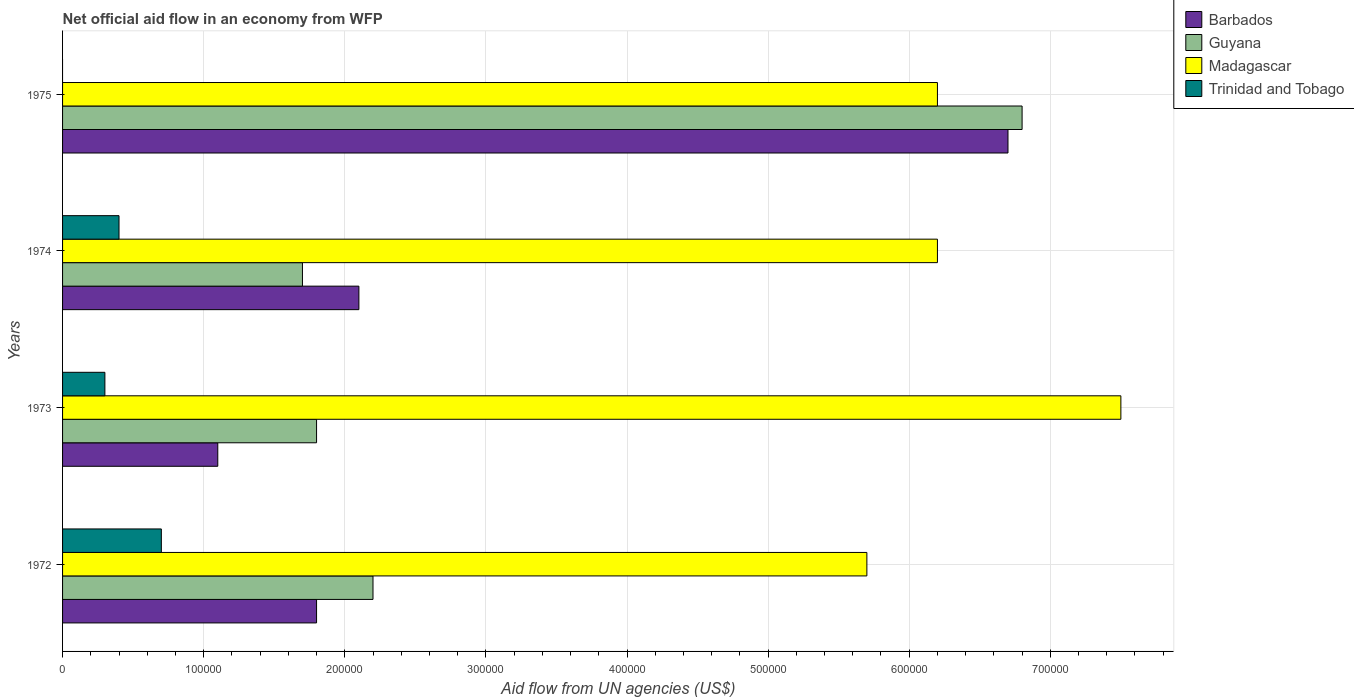How many groups of bars are there?
Your answer should be very brief. 4. How many bars are there on the 4th tick from the top?
Your answer should be compact. 4. What is the label of the 1st group of bars from the top?
Keep it short and to the point. 1975. What is the net official aid flow in Madagascar in 1973?
Provide a succinct answer. 7.50e+05. Across all years, what is the maximum net official aid flow in Trinidad and Tobago?
Provide a succinct answer. 7.00e+04. In which year was the net official aid flow in Barbados maximum?
Ensure brevity in your answer.  1975. What is the total net official aid flow in Barbados in the graph?
Your response must be concise. 1.17e+06. What is the difference between the net official aid flow in Guyana in 1973 and that in 1975?
Your answer should be compact. -5.00e+05. What is the average net official aid flow in Guyana per year?
Ensure brevity in your answer.  3.12e+05. In the year 1975, what is the difference between the net official aid flow in Barbados and net official aid flow in Guyana?
Keep it short and to the point. -10000. In how many years, is the net official aid flow in Madagascar greater than 120000 US$?
Give a very brief answer. 4. What is the ratio of the net official aid flow in Barbados in 1972 to that in 1973?
Provide a succinct answer. 1.64. What is the difference between the highest and the second highest net official aid flow in Trinidad and Tobago?
Keep it short and to the point. 3.00e+04. What is the difference between the highest and the lowest net official aid flow in Guyana?
Your answer should be compact. 5.10e+05. Is the sum of the net official aid flow in Barbados in 1973 and 1975 greater than the maximum net official aid flow in Madagascar across all years?
Make the answer very short. Yes. Is it the case that in every year, the sum of the net official aid flow in Barbados and net official aid flow in Madagascar is greater than the sum of net official aid flow in Guyana and net official aid flow in Trinidad and Tobago?
Offer a terse response. No. Is it the case that in every year, the sum of the net official aid flow in Trinidad and Tobago and net official aid flow in Guyana is greater than the net official aid flow in Barbados?
Offer a terse response. No. Are all the bars in the graph horizontal?
Your response must be concise. Yes. How many years are there in the graph?
Provide a succinct answer. 4. Does the graph contain any zero values?
Ensure brevity in your answer.  Yes. Does the graph contain grids?
Your answer should be compact. Yes. How are the legend labels stacked?
Offer a terse response. Vertical. What is the title of the graph?
Your answer should be very brief. Net official aid flow in an economy from WFP. Does "Bosnia and Herzegovina" appear as one of the legend labels in the graph?
Provide a succinct answer. No. What is the label or title of the X-axis?
Offer a very short reply. Aid flow from UN agencies (US$). What is the label or title of the Y-axis?
Provide a short and direct response. Years. What is the Aid flow from UN agencies (US$) of Madagascar in 1972?
Your answer should be very brief. 5.70e+05. What is the Aid flow from UN agencies (US$) of Trinidad and Tobago in 1972?
Offer a terse response. 7.00e+04. What is the Aid flow from UN agencies (US$) of Barbados in 1973?
Give a very brief answer. 1.10e+05. What is the Aid flow from UN agencies (US$) in Guyana in 1973?
Ensure brevity in your answer.  1.80e+05. What is the Aid flow from UN agencies (US$) in Madagascar in 1973?
Ensure brevity in your answer.  7.50e+05. What is the Aid flow from UN agencies (US$) of Trinidad and Tobago in 1973?
Offer a very short reply. 3.00e+04. What is the Aid flow from UN agencies (US$) of Barbados in 1974?
Your response must be concise. 2.10e+05. What is the Aid flow from UN agencies (US$) of Madagascar in 1974?
Make the answer very short. 6.20e+05. What is the Aid flow from UN agencies (US$) of Barbados in 1975?
Provide a succinct answer. 6.70e+05. What is the Aid flow from UN agencies (US$) of Guyana in 1975?
Provide a short and direct response. 6.80e+05. What is the Aid flow from UN agencies (US$) in Madagascar in 1975?
Make the answer very short. 6.20e+05. What is the Aid flow from UN agencies (US$) in Trinidad and Tobago in 1975?
Make the answer very short. 0. Across all years, what is the maximum Aid flow from UN agencies (US$) in Barbados?
Your answer should be compact. 6.70e+05. Across all years, what is the maximum Aid flow from UN agencies (US$) of Guyana?
Your answer should be compact. 6.80e+05. Across all years, what is the maximum Aid flow from UN agencies (US$) of Madagascar?
Offer a very short reply. 7.50e+05. Across all years, what is the maximum Aid flow from UN agencies (US$) in Trinidad and Tobago?
Provide a short and direct response. 7.00e+04. Across all years, what is the minimum Aid flow from UN agencies (US$) of Madagascar?
Provide a short and direct response. 5.70e+05. Across all years, what is the minimum Aid flow from UN agencies (US$) of Trinidad and Tobago?
Offer a terse response. 0. What is the total Aid flow from UN agencies (US$) of Barbados in the graph?
Give a very brief answer. 1.17e+06. What is the total Aid flow from UN agencies (US$) in Guyana in the graph?
Give a very brief answer. 1.25e+06. What is the total Aid flow from UN agencies (US$) in Madagascar in the graph?
Provide a short and direct response. 2.56e+06. What is the total Aid flow from UN agencies (US$) of Trinidad and Tobago in the graph?
Ensure brevity in your answer.  1.40e+05. What is the difference between the Aid flow from UN agencies (US$) in Barbados in 1972 and that in 1973?
Your answer should be compact. 7.00e+04. What is the difference between the Aid flow from UN agencies (US$) of Trinidad and Tobago in 1972 and that in 1973?
Provide a succinct answer. 4.00e+04. What is the difference between the Aid flow from UN agencies (US$) in Guyana in 1972 and that in 1974?
Offer a terse response. 5.00e+04. What is the difference between the Aid flow from UN agencies (US$) of Barbados in 1972 and that in 1975?
Make the answer very short. -4.90e+05. What is the difference between the Aid flow from UN agencies (US$) of Guyana in 1972 and that in 1975?
Offer a terse response. -4.60e+05. What is the difference between the Aid flow from UN agencies (US$) in Madagascar in 1972 and that in 1975?
Offer a terse response. -5.00e+04. What is the difference between the Aid flow from UN agencies (US$) in Guyana in 1973 and that in 1974?
Make the answer very short. 10000. What is the difference between the Aid flow from UN agencies (US$) of Barbados in 1973 and that in 1975?
Offer a very short reply. -5.60e+05. What is the difference between the Aid flow from UN agencies (US$) of Guyana in 1973 and that in 1975?
Your answer should be compact. -5.00e+05. What is the difference between the Aid flow from UN agencies (US$) in Madagascar in 1973 and that in 1975?
Keep it short and to the point. 1.30e+05. What is the difference between the Aid flow from UN agencies (US$) of Barbados in 1974 and that in 1975?
Ensure brevity in your answer.  -4.60e+05. What is the difference between the Aid flow from UN agencies (US$) of Guyana in 1974 and that in 1975?
Give a very brief answer. -5.10e+05. What is the difference between the Aid flow from UN agencies (US$) of Madagascar in 1974 and that in 1975?
Your response must be concise. 0. What is the difference between the Aid flow from UN agencies (US$) in Barbados in 1972 and the Aid flow from UN agencies (US$) in Madagascar in 1973?
Your response must be concise. -5.70e+05. What is the difference between the Aid flow from UN agencies (US$) in Guyana in 1972 and the Aid flow from UN agencies (US$) in Madagascar in 1973?
Your response must be concise. -5.30e+05. What is the difference between the Aid flow from UN agencies (US$) in Madagascar in 1972 and the Aid flow from UN agencies (US$) in Trinidad and Tobago in 1973?
Offer a very short reply. 5.40e+05. What is the difference between the Aid flow from UN agencies (US$) of Barbados in 1972 and the Aid flow from UN agencies (US$) of Madagascar in 1974?
Your answer should be very brief. -4.40e+05. What is the difference between the Aid flow from UN agencies (US$) in Barbados in 1972 and the Aid flow from UN agencies (US$) in Trinidad and Tobago in 1974?
Ensure brevity in your answer.  1.40e+05. What is the difference between the Aid flow from UN agencies (US$) of Guyana in 1972 and the Aid flow from UN agencies (US$) of Madagascar in 1974?
Provide a succinct answer. -4.00e+05. What is the difference between the Aid flow from UN agencies (US$) in Guyana in 1972 and the Aid flow from UN agencies (US$) in Trinidad and Tobago in 1974?
Your answer should be compact. 1.80e+05. What is the difference between the Aid flow from UN agencies (US$) of Madagascar in 1972 and the Aid flow from UN agencies (US$) of Trinidad and Tobago in 1974?
Your response must be concise. 5.30e+05. What is the difference between the Aid flow from UN agencies (US$) of Barbados in 1972 and the Aid flow from UN agencies (US$) of Guyana in 1975?
Provide a short and direct response. -5.00e+05. What is the difference between the Aid flow from UN agencies (US$) in Barbados in 1972 and the Aid flow from UN agencies (US$) in Madagascar in 1975?
Offer a very short reply. -4.40e+05. What is the difference between the Aid flow from UN agencies (US$) in Guyana in 1972 and the Aid flow from UN agencies (US$) in Madagascar in 1975?
Ensure brevity in your answer.  -4.00e+05. What is the difference between the Aid flow from UN agencies (US$) in Barbados in 1973 and the Aid flow from UN agencies (US$) in Guyana in 1974?
Keep it short and to the point. -6.00e+04. What is the difference between the Aid flow from UN agencies (US$) in Barbados in 1973 and the Aid flow from UN agencies (US$) in Madagascar in 1974?
Provide a short and direct response. -5.10e+05. What is the difference between the Aid flow from UN agencies (US$) in Barbados in 1973 and the Aid flow from UN agencies (US$) in Trinidad and Tobago in 1974?
Keep it short and to the point. 7.00e+04. What is the difference between the Aid flow from UN agencies (US$) in Guyana in 1973 and the Aid flow from UN agencies (US$) in Madagascar in 1974?
Provide a succinct answer. -4.40e+05. What is the difference between the Aid flow from UN agencies (US$) of Guyana in 1973 and the Aid flow from UN agencies (US$) of Trinidad and Tobago in 1974?
Provide a short and direct response. 1.40e+05. What is the difference between the Aid flow from UN agencies (US$) of Madagascar in 1973 and the Aid flow from UN agencies (US$) of Trinidad and Tobago in 1974?
Offer a terse response. 7.10e+05. What is the difference between the Aid flow from UN agencies (US$) in Barbados in 1973 and the Aid flow from UN agencies (US$) in Guyana in 1975?
Offer a terse response. -5.70e+05. What is the difference between the Aid flow from UN agencies (US$) of Barbados in 1973 and the Aid flow from UN agencies (US$) of Madagascar in 1975?
Your response must be concise. -5.10e+05. What is the difference between the Aid flow from UN agencies (US$) in Guyana in 1973 and the Aid flow from UN agencies (US$) in Madagascar in 1975?
Keep it short and to the point. -4.40e+05. What is the difference between the Aid flow from UN agencies (US$) in Barbados in 1974 and the Aid flow from UN agencies (US$) in Guyana in 1975?
Give a very brief answer. -4.70e+05. What is the difference between the Aid flow from UN agencies (US$) of Barbados in 1974 and the Aid flow from UN agencies (US$) of Madagascar in 1975?
Provide a succinct answer. -4.10e+05. What is the difference between the Aid flow from UN agencies (US$) of Guyana in 1974 and the Aid flow from UN agencies (US$) of Madagascar in 1975?
Offer a very short reply. -4.50e+05. What is the average Aid flow from UN agencies (US$) of Barbados per year?
Provide a succinct answer. 2.92e+05. What is the average Aid flow from UN agencies (US$) in Guyana per year?
Offer a terse response. 3.12e+05. What is the average Aid flow from UN agencies (US$) of Madagascar per year?
Your response must be concise. 6.40e+05. What is the average Aid flow from UN agencies (US$) in Trinidad and Tobago per year?
Keep it short and to the point. 3.50e+04. In the year 1972, what is the difference between the Aid flow from UN agencies (US$) in Barbados and Aid flow from UN agencies (US$) in Madagascar?
Your answer should be very brief. -3.90e+05. In the year 1972, what is the difference between the Aid flow from UN agencies (US$) in Guyana and Aid flow from UN agencies (US$) in Madagascar?
Your response must be concise. -3.50e+05. In the year 1972, what is the difference between the Aid flow from UN agencies (US$) of Guyana and Aid flow from UN agencies (US$) of Trinidad and Tobago?
Make the answer very short. 1.50e+05. In the year 1972, what is the difference between the Aid flow from UN agencies (US$) of Madagascar and Aid flow from UN agencies (US$) of Trinidad and Tobago?
Your answer should be very brief. 5.00e+05. In the year 1973, what is the difference between the Aid flow from UN agencies (US$) of Barbados and Aid flow from UN agencies (US$) of Madagascar?
Make the answer very short. -6.40e+05. In the year 1973, what is the difference between the Aid flow from UN agencies (US$) of Guyana and Aid flow from UN agencies (US$) of Madagascar?
Offer a very short reply. -5.70e+05. In the year 1973, what is the difference between the Aid flow from UN agencies (US$) of Madagascar and Aid flow from UN agencies (US$) of Trinidad and Tobago?
Keep it short and to the point. 7.20e+05. In the year 1974, what is the difference between the Aid flow from UN agencies (US$) of Barbados and Aid flow from UN agencies (US$) of Guyana?
Your answer should be very brief. 4.00e+04. In the year 1974, what is the difference between the Aid flow from UN agencies (US$) in Barbados and Aid flow from UN agencies (US$) in Madagascar?
Keep it short and to the point. -4.10e+05. In the year 1974, what is the difference between the Aid flow from UN agencies (US$) of Guyana and Aid flow from UN agencies (US$) of Madagascar?
Keep it short and to the point. -4.50e+05. In the year 1974, what is the difference between the Aid flow from UN agencies (US$) in Guyana and Aid flow from UN agencies (US$) in Trinidad and Tobago?
Ensure brevity in your answer.  1.30e+05. In the year 1974, what is the difference between the Aid flow from UN agencies (US$) of Madagascar and Aid flow from UN agencies (US$) of Trinidad and Tobago?
Give a very brief answer. 5.80e+05. In the year 1975, what is the difference between the Aid flow from UN agencies (US$) in Barbados and Aid flow from UN agencies (US$) in Madagascar?
Your answer should be very brief. 5.00e+04. In the year 1975, what is the difference between the Aid flow from UN agencies (US$) of Guyana and Aid flow from UN agencies (US$) of Madagascar?
Your answer should be compact. 6.00e+04. What is the ratio of the Aid flow from UN agencies (US$) in Barbados in 1972 to that in 1973?
Make the answer very short. 1.64. What is the ratio of the Aid flow from UN agencies (US$) in Guyana in 1972 to that in 1973?
Ensure brevity in your answer.  1.22. What is the ratio of the Aid flow from UN agencies (US$) in Madagascar in 1972 to that in 1973?
Offer a very short reply. 0.76. What is the ratio of the Aid flow from UN agencies (US$) in Trinidad and Tobago in 1972 to that in 1973?
Your response must be concise. 2.33. What is the ratio of the Aid flow from UN agencies (US$) in Barbados in 1972 to that in 1974?
Your answer should be compact. 0.86. What is the ratio of the Aid flow from UN agencies (US$) of Guyana in 1972 to that in 1974?
Offer a very short reply. 1.29. What is the ratio of the Aid flow from UN agencies (US$) in Madagascar in 1972 to that in 1974?
Provide a succinct answer. 0.92. What is the ratio of the Aid flow from UN agencies (US$) of Trinidad and Tobago in 1972 to that in 1974?
Offer a very short reply. 1.75. What is the ratio of the Aid flow from UN agencies (US$) of Barbados in 1972 to that in 1975?
Provide a succinct answer. 0.27. What is the ratio of the Aid flow from UN agencies (US$) in Guyana in 1972 to that in 1975?
Offer a very short reply. 0.32. What is the ratio of the Aid flow from UN agencies (US$) in Madagascar in 1972 to that in 1975?
Provide a short and direct response. 0.92. What is the ratio of the Aid flow from UN agencies (US$) in Barbados in 1973 to that in 1974?
Keep it short and to the point. 0.52. What is the ratio of the Aid flow from UN agencies (US$) in Guyana in 1973 to that in 1974?
Offer a terse response. 1.06. What is the ratio of the Aid flow from UN agencies (US$) of Madagascar in 1973 to that in 1974?
Your answer should be compact. 1.21. What is the ratio of the Aid flow from UN agencies (US$) of Barbados in 1973 to that in 1975?
Your answer should be compact. 0.16. What is the ratio of the Aid flow from UN agencies (US$) in Guyana in 1973 to that in 1975?
Make the answer very short. 0.26. What is the ratio of the Aid flow from UN agencies (US$) of Madagascar in 1973 to that in 1975?
Your answer should be compact. 1.21. What is the ratio of the Aid flow from UN agencies (US$) of Barbados in 1974 to that in 1975?
Offer a very short reply. 0.31. What is the ratio of the Aid flow from UN agencies (US$) in Madagascar in 1974 to that in 1975?
Your response must be concise. 1. What is the difference between the highest and the second highest Aid flow from UN agencies (US$) in Barbados?
Offer a terse response. 4.60e+05. What is the difference between the highest and the second highest Aid flow from UN agencies (US$) in Guyana?
Your answer should be very brief. 4.60e+05. What is the difference between the highest and the second highest Aid flow from UN agencies (US$) of Madagascar?
Your answer should be very brief. 1.30e+05. What is the difference between the highest and the lowest Aid flow from UN agencies (US$) in Barbados?
Your answer should be compact. 5.60e+05. What is the difference between the highest and the lowest Aid flow from UN agencies (US$) in Guyana?
Your answer should be very brief. 5.10e+05. What is the difference between the highest and the lowest Aid flow from UN agencies (US$) of Trinidad and Tobago?
Your answer should be very brief. 7.00e+04. 